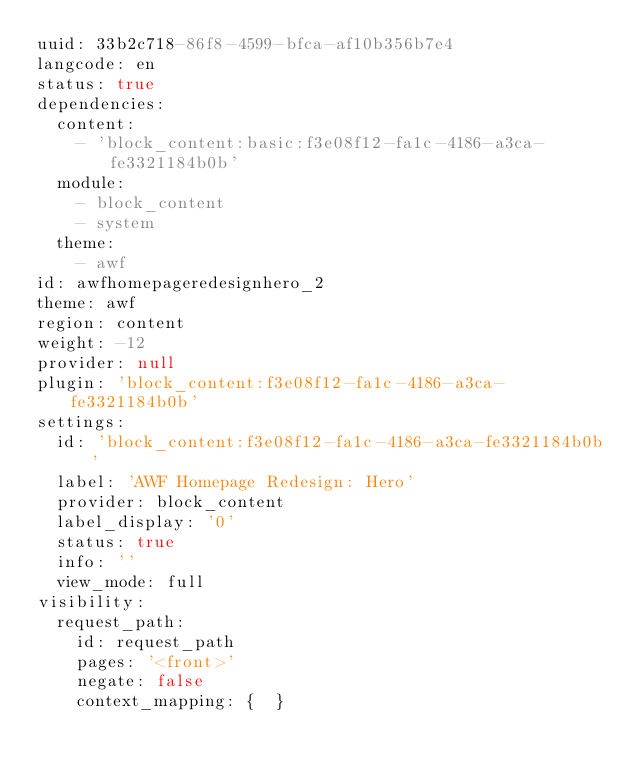Convert code to text. <code><loc_0><loc_0><loc_500><loc_500><_YAML_>uuid: 33b2c718-86f8-4599-bfca-af10b356b7e4
langcode: en
status: true
dependencies:
  content:
    - 'block_content:basic:f3e08f12-fa1c-4186-a3ca-fe3321184b0b'
  module:
    - block_content
    - system
  theme:
    - awf
id: awfhomepageredesignhero_2
theme: awf
region: content
weight: -12
provider: null
plugin: 'block_content:f3e08f12-fa1c-4186-a3ca-fe3321184b0b'
settings:
  id: 'block_content:f3e08f12-fa1c-4186-a3ca-fe3321184b0b'
  label: 'AWF Homepage Redesign: Hero'
  provider: block_content
  label_display: '0'
  status: true
  info: ''
  view_mode: full
visibility:
  request_path:
    id: request_path
    pages: '<front>'
    negate: false
    context_mapping: {  }
</code> 